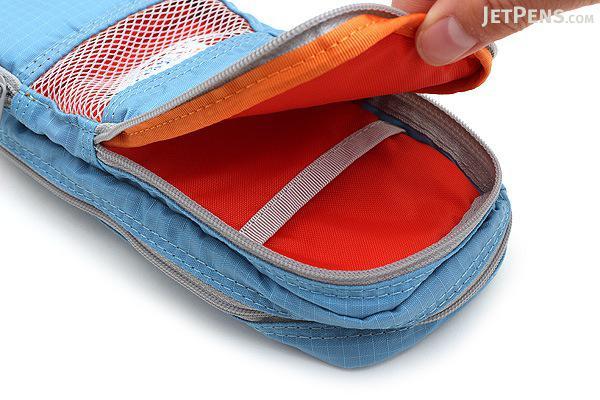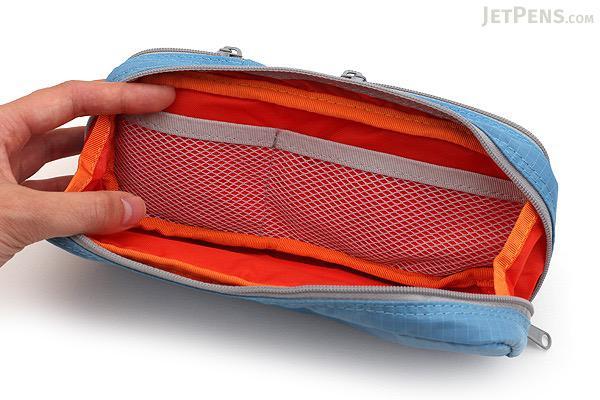The first image is the image on the left, the second image is the image on the right. Evaluate the accuracy of this statement regarding the images: "Two light blue pencil bags are unzipped and showing the inside.". Is it true? Answer yes or no. Yes. The first image is the image on the left, the second image is the image on the right. For the images displayed, is the sentence "there is a mesh pocket on the front of a pencil case" factually correct? Answer yes or no. Yes. 